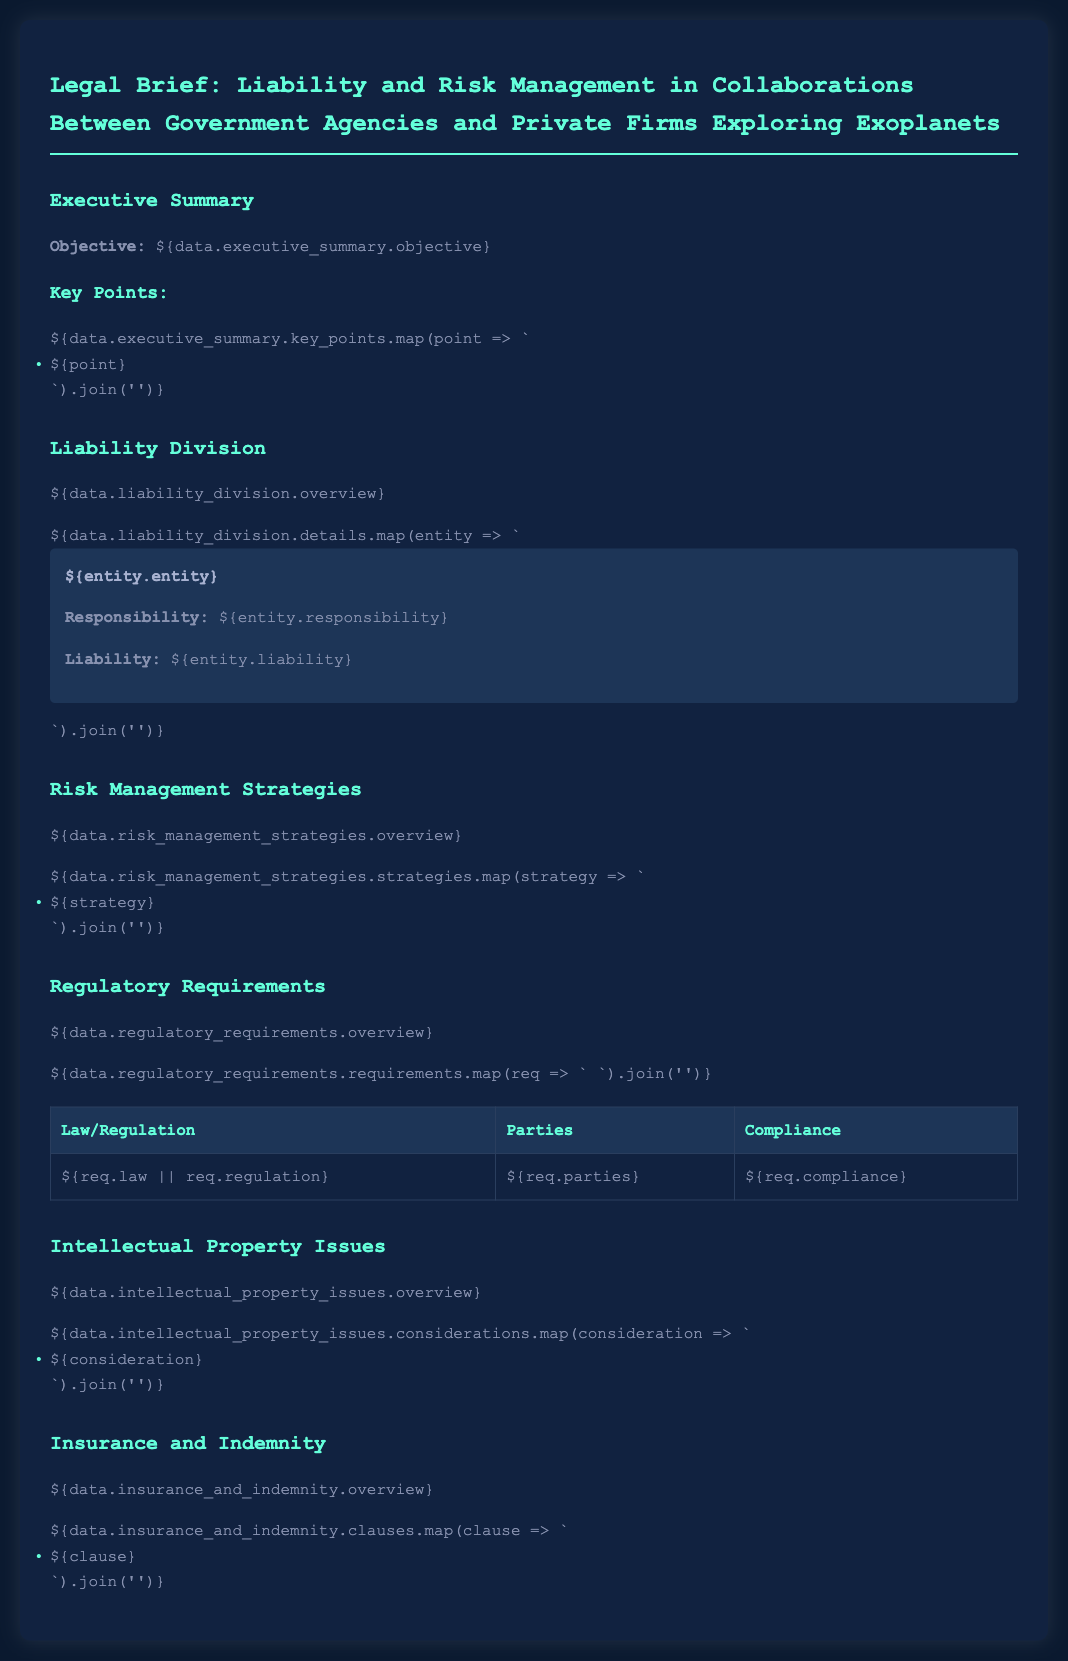what is the objective of the document? The objective of the document is stated in the executive summary section, summarizing the main goal or aim of the legal brief.
Answer: Legal briefs regarding liability and risk management in collaborations what is one key point discussed in the document? The document lists several key points in the executive summary; one can be retrieved from that section.
Answer: Collaboration between government and private entities what is the overview of liability division? The overview is part of the liability division section, giving a brief description of this aspect.
Answer: Overview outlines responsibility allocation who is responsible for liability in the collaboration? The document specifies several entities and their responsibilities in the liability division section.
Answer: Government agencies and private firms how many strategies are listed in risk management? The total number of strategies can be counted from the list provided under risk management strategies.
Answer: Number of strategies is unspecified what does the insurance and indemnity section address? The section overview provides a brief description of the topics covered regarding insurance and indemnity.
Answer: Overview addresses liability coverage and indemnity claims what type of issues are highlighted in the intellectual property section? The considerations specifically mention various issues related to intellectual property within the context of the document.
Answer: Ownership, rights, and patents what is one regulatory requirement mentioned? The requirements section includes several laws and regulations; one can be pulled directly from this table.
Answer: Federal Agency Compliance Act 